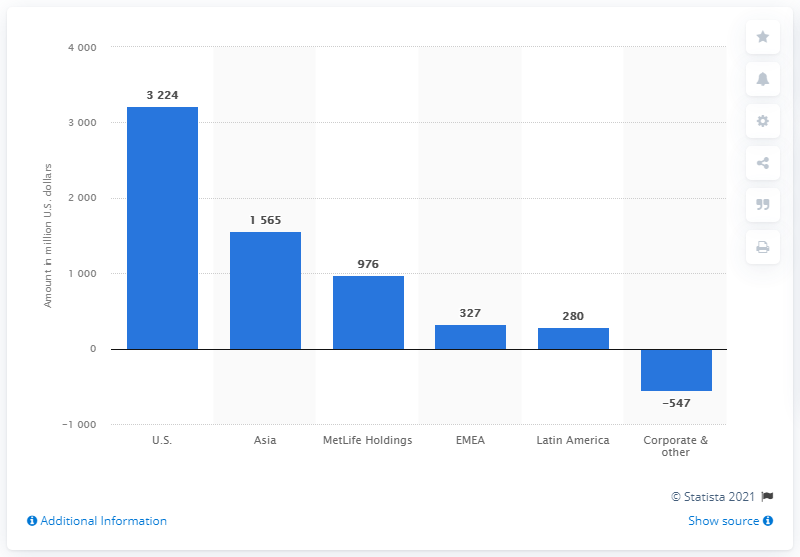Give some essential details in this illustration. The operating earnings from the U.S. segment in 2020 were approximately $3,224 in dollars. 